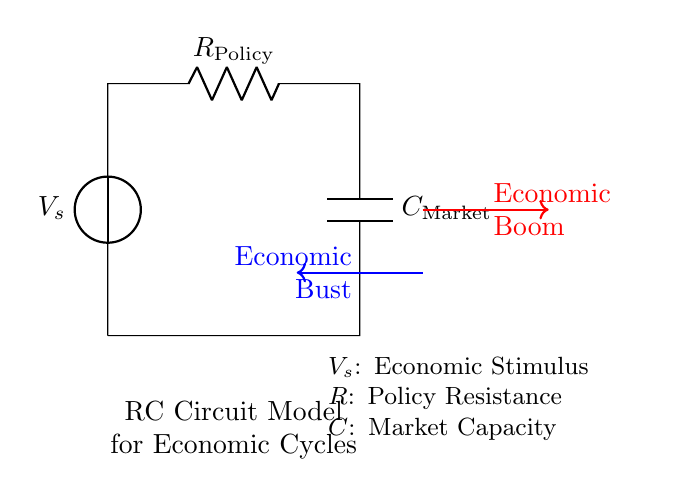What is the voltage source in this circuit? The voltage source, labeled as V_s, represents the external economic stimulus that influences the circuit. It is the starting point of the circuit and is crucial for driving current through the components.
Answer: V_s What does the resistor represent? The resistor, labeled as R_policy, symbolizes policy resistance in economic terms. It impedes the flow of economic recovery or resistance to changes in policy, which can affect how quickly the economy can respond to stimuli.
Answer: R_policy What does the capacitor symbolize? The capacitor, labeled as C_market, represents the market's capacity to absorb or store economic stimuli. It reflects the market's ability to handle bursts of economic activity or investment over time before it reaches its limit.
Answer: C_market What direction does the economic boom flow? The economic boom direction is indicated by the red arrow going from left to right, demonstrating the flow of positive economic growth resulting from the stimulus.
Answer: Right What is the direction of the economic bust flow? The economic bust direction is indicated by the blue arrow moving from right to left, which represents a negative downturn in the economy caused by various factors, possibly including policy decisions or market overcapacity.
Answer: Left How are the components connected in this RC circuit? The components in this RC circuit are connected in series; the voltage source first connects to the resistor, and then the resistor connects to the capacitor, forming a continuous loop.
Answer: In series Which component is primarily responsible for responding to the economic stimulus? The capacitor, due to its nature of storing and releasing energy, is primarily responsible for responding to the economic stimulus by influencing market reactions over time.
Answer: Capacitor 